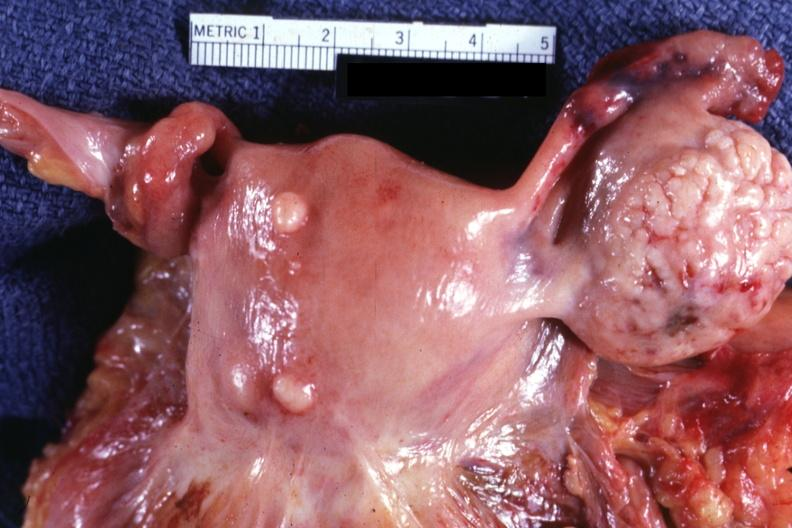s leiomyomas present?
Answer the question using a single word or phrase. Yes 